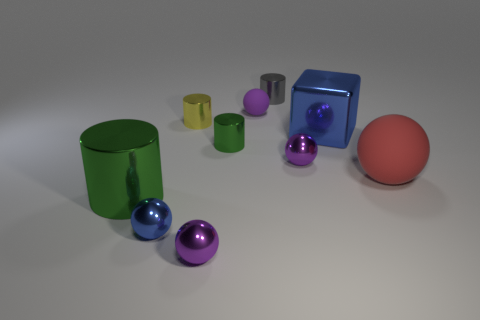Subtract all purple spheres. How many were subtracted if there are1purple spheres left? 2 Subtract all blue cubes. How many purple spheres are left? 3 Subtract all blue balls. How many balls are left? 4 Subtract all big red rubber balls. How many balls are left? 4 Subtract all gray spheres. Subtract all purple blocks. How many spheres are left? 5 Subtract all cylinders. How many objects are left? 6 Subtract all small purple rubber balls. Subtract all yellow metallic things. How many objects are left? 8 Add 3 tiny objects. How many tiny objects are left? 10 Add 1 small balls. How many small balls exist? 5 Subtract 0 purple cylinders. How many objects are left? 10 